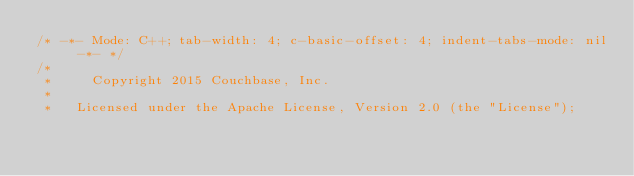<code> <loc_0><loc_0><loc_500><loc_500><_C_>/* -*- Mode: C++; tab-width: 4; c-basic-offset: 4; indent-tabs-mode: nil -*- */
/*
 *     Copyright 2015 Couchbase, Inc.
 *
 *   Licensed under the Apache License, Version 2.0 (the "License");</code> 